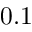Convert formula to latex. <formula><loc_0><loc_0><loc_500><loc_500>0 . 1</formula> 